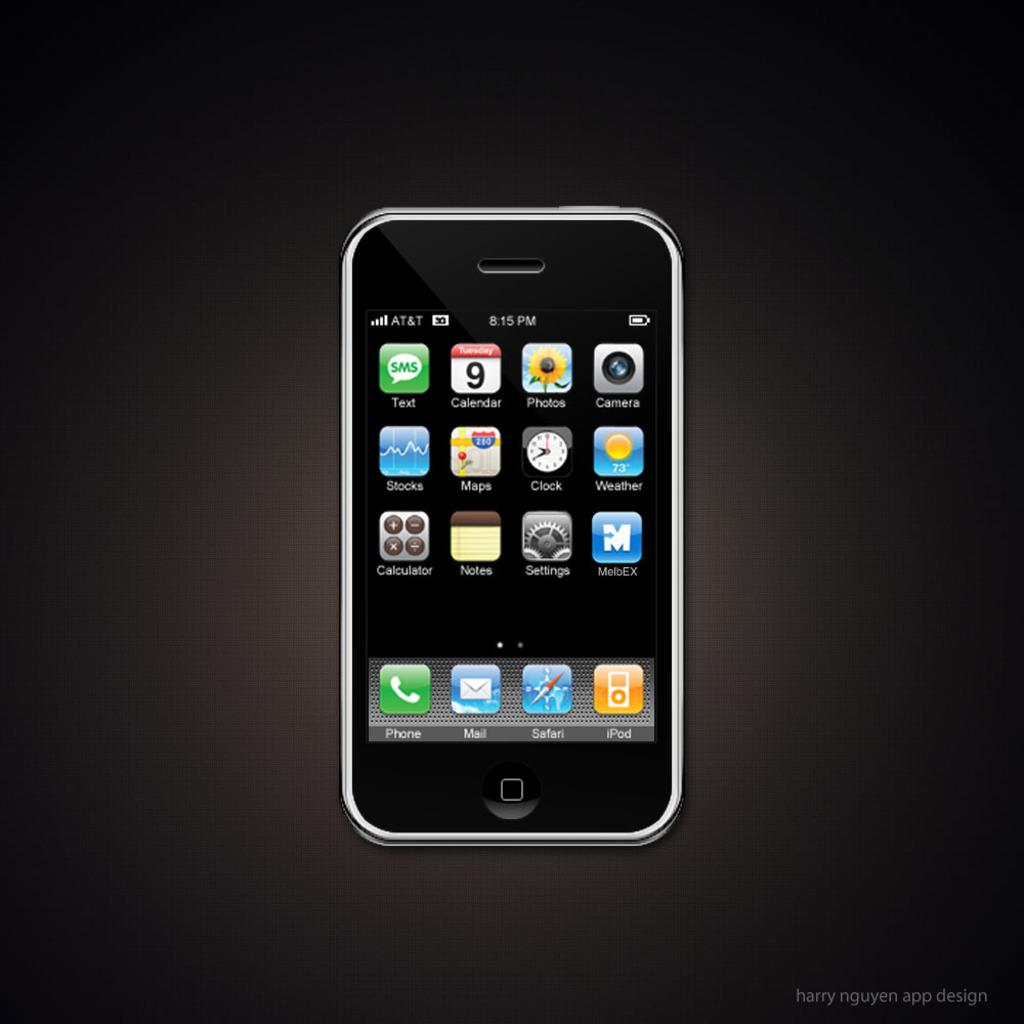<image>
Render a clear and concise summary of the photo. Iphone that show the home screen that contains different apps 